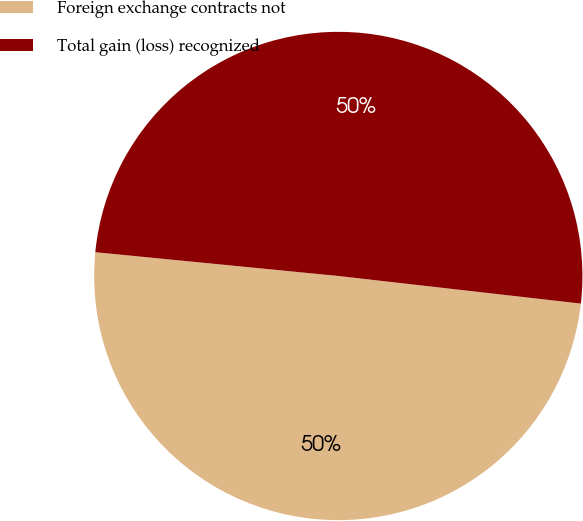<chart> <loc_0><loc_0><loc_500><loc_500><pie_chart><fcel>Foreign exchange contracts not<fcel>Total gain (loss) recognized<nl><fcel>49.75%<fcel>50.25%<nl></chart> 